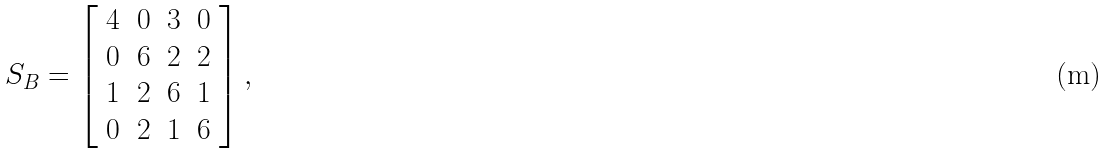<formula> <loc_0><loc_0><loc_500><loc_500>S _ { B } = \left [ \begin{array} { c c c c } 4 & 0 & 3 & 0 \\ 0 & 6 & 2 & 2 \\ 1 & 2 & 6 & 1 \\ 0 & 2 & 1 & 6 \\ \end{array} \right ] ,</formula> 